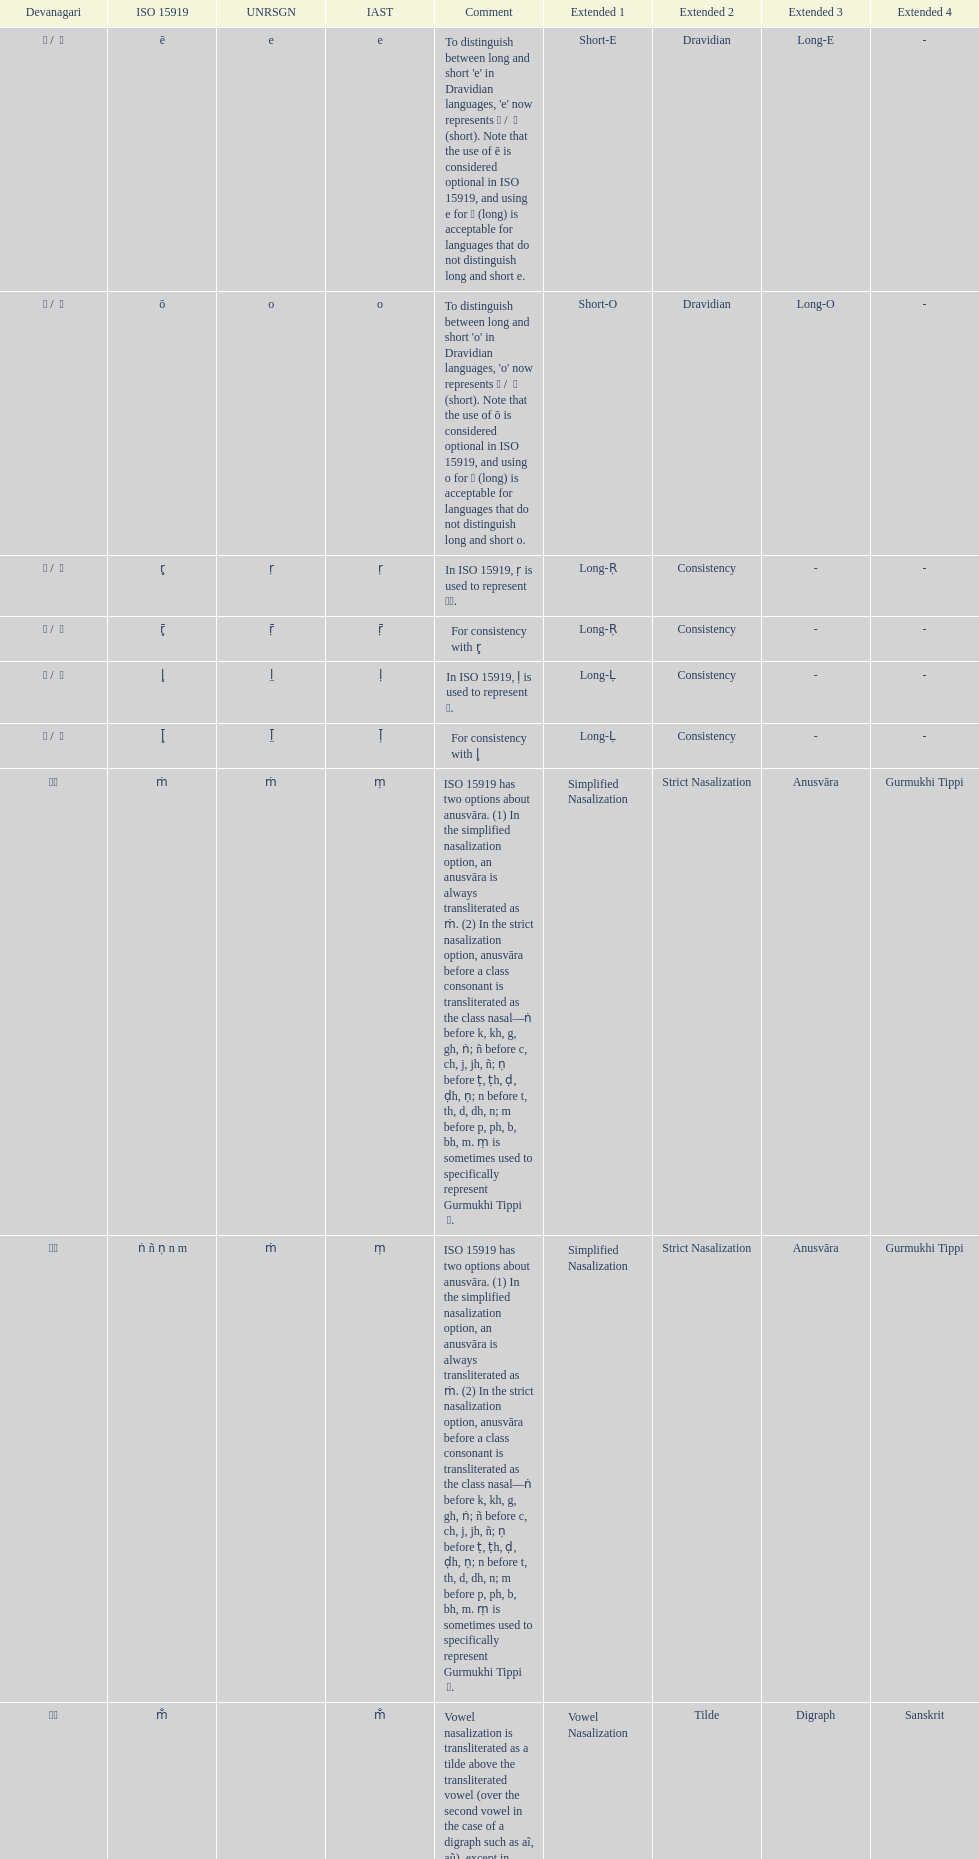Which devanagari transliteration is listed on the top of the table? ए / े. 